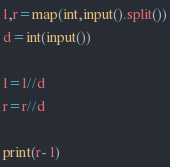Convert code to text. <code><loc_0><loc_0><loc_500><loc_500><_Python_>l,r=map(int,input().split())
d=int(input())

l=l//d
r=r//d

print(r- l)
</code> 